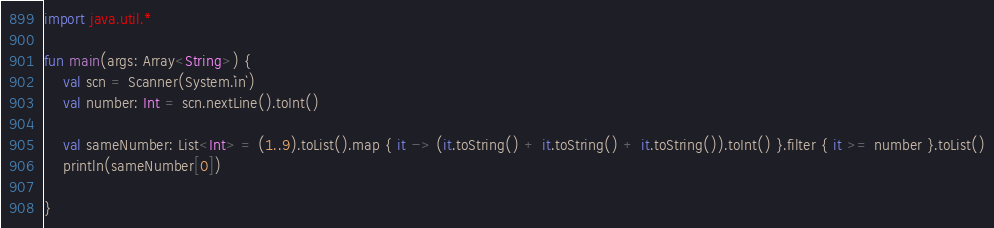<code> <loc_0><loc_0><loc_500><loc_500><_Kotlin_>import java.util.*

fun main(args: Array<String>) {
    val scn = Scanner(System.`in`)
    val number: Int = scn.nextLine().toInt()

    val sameNumber: List<Int> = (1..9).toList().map { it -> (it.toString() + it.toString() + it.toString()).toInt() }.filter { it >= number }.toList()
    println(sameNumber[0])

}</code> 